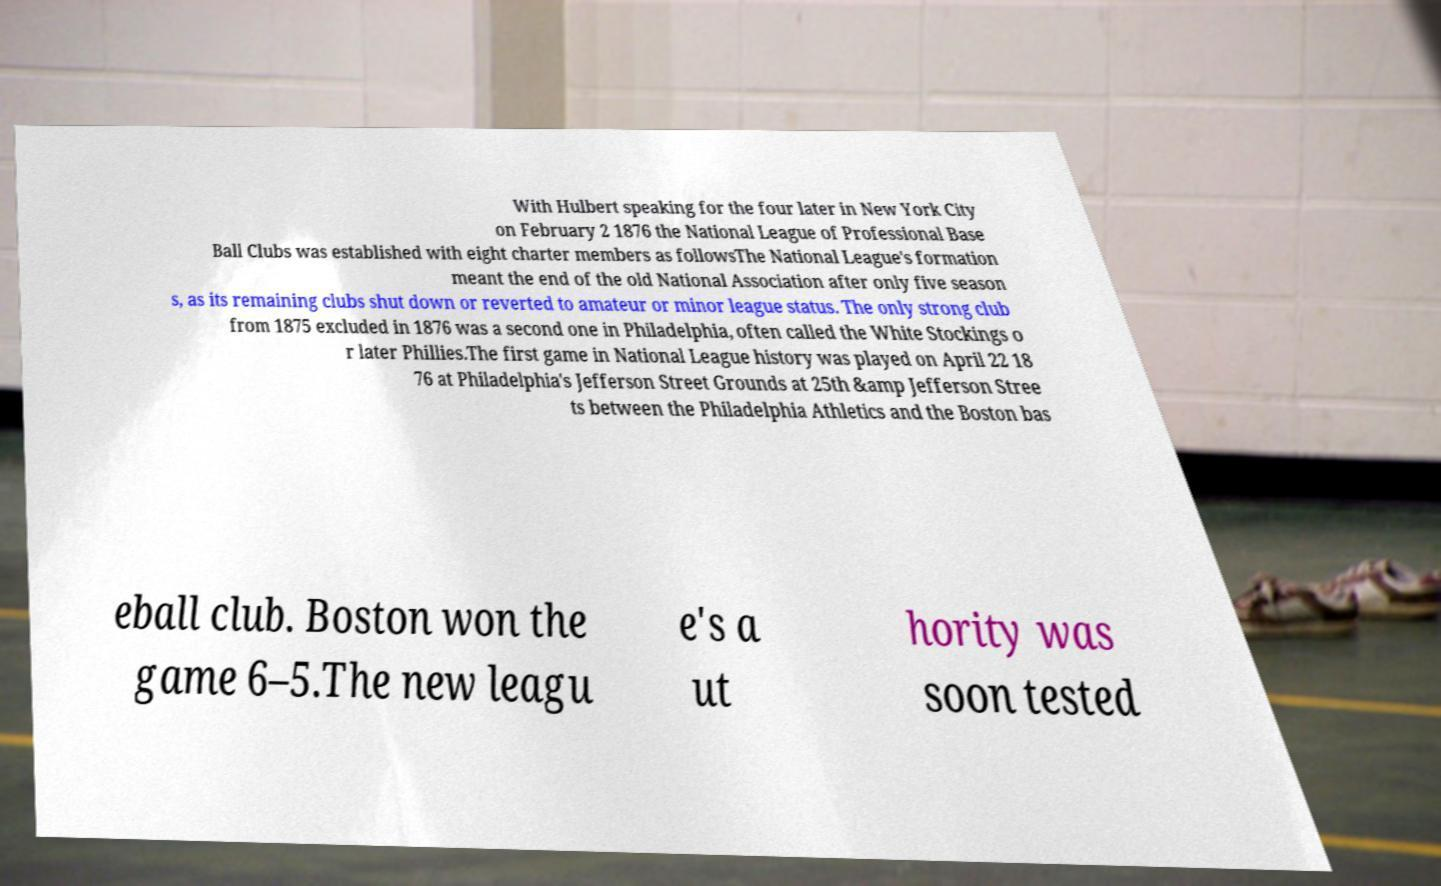Please read and relay the text visible in this image. What does it say? With Hulbert speaking for the four later in New York City on February 2 1876 the National League of Professional Base Ball Clubs was established with eight charter members as followsThe National League's formation meant the end of the old National Association after only five season s, as its remaining clubs shut down or reverted to amateur or minor league status. The only strong club from 1875 excluded in 1876 was a second one in Philadelphia, often called the White Stockings o r later Phillies.The first game in National League history was played on April 22 18 76 at Philadelphia's Jefferson Street Grounds at 25th &amp Jefferson Stree ts between the Philadelphia Athletics and the Boston bas eball club. Boston won the game 6–5.The new leagu e's a ut hority was soon tested 